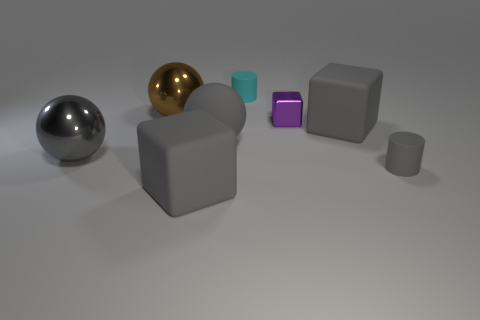What shape is the brown thing that is the same material as the purple block?
Offer a very short reply. Sphere. There is a tiny gray cylinder; how many gray rubber cubes are left of it?
Offer a terse response. 2. Is the number of small matte objects in front of the tiny purple cube the same as the number of small purple metallic cubes?
Keep it short and to the point. Yes. Are the large brown thing and the small purple object made of the same material?
Ensure brevity in your answer.  Yes. What is the size of the thing that is behind the purple cube and to the right of the brown metal sphere?
Your answer should be very brief. Small. What number of blocks have the same size as the gray shiny thing?
Make the answer very short. 2. What is the size of the cylinder that is behind the large brown sphere to the left of the cyan matte object?
Your answer should be very brief. Small. There is a small gray rubber object that is in front of the tiny metal thing; does it have the same shape as the rubber thing that is behind the large brown metal object?
Your response must be concise. Yes. The thing that is both to the right of the large brown shiny ball and behind the small metallic thing is what color?
Keep it short and to the point. Cyan. Is there a rubber cylinder of the same color as the rubber ball?
Offer a very short reply. Yes. 